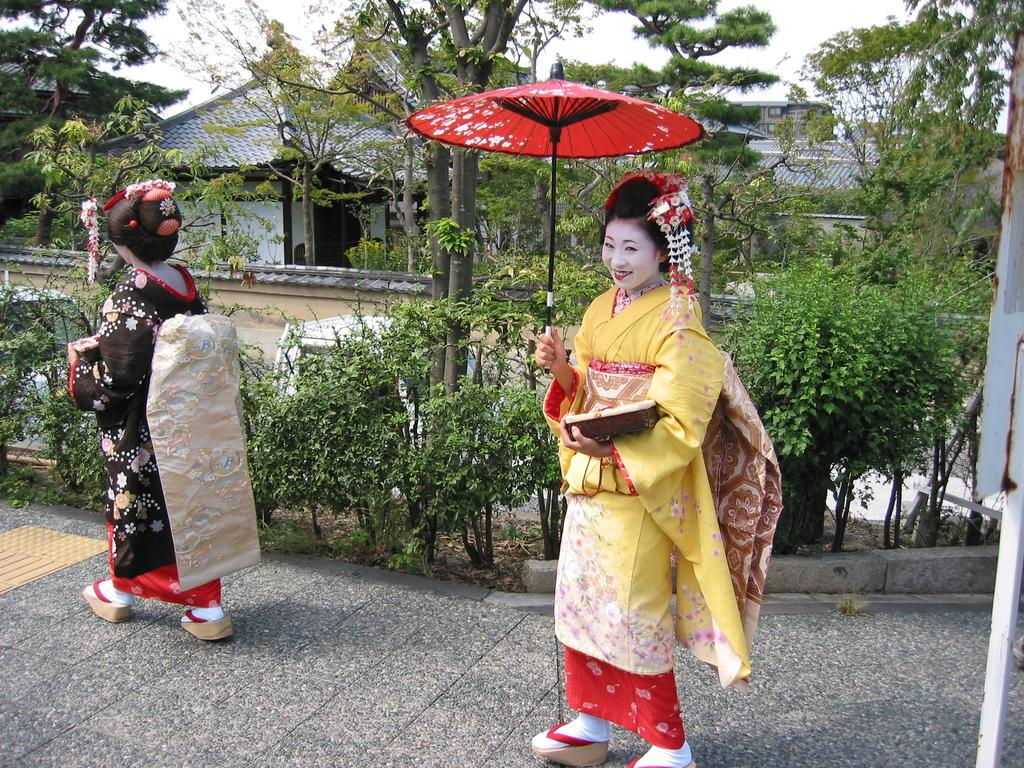Who is present in the image? There are women in the image. What are the women wearing? The women are dressed in traditional Japanese attire. Can you describe any specific accessory one of the women is holding? One woman is holding an umbrella. What can be seen in the background of the image? There are trees and a building in the background of the image. What type of protest is taking place in the image? There is no protest present in the image; it features women dressed in traditional Japanese attire, one of whom is holding an umbrella, with trees and a building in the background. Can you tell me what time it is according to the clock in the image? There is no clock present in the image. 